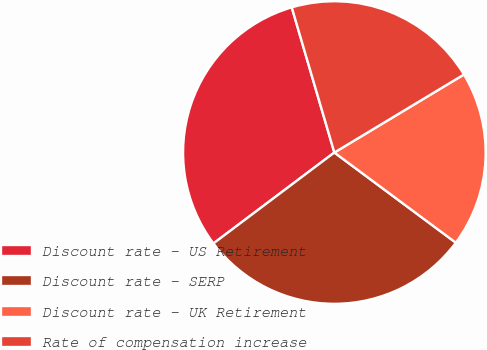Convert chart to OTSL. <chart><loc_0><loc_0><loc_500><loc_500><pie_chart><fcel>Discount rate - US Retirement<fcel>Discount rate - SERP<fcel>Discount rate - UK Retirement<fcel>Rate of compensation increase<nl><fcel>30.72%<fcel>29.58%<fcel>18.79%<fcel>20.92%<nl></chart> 